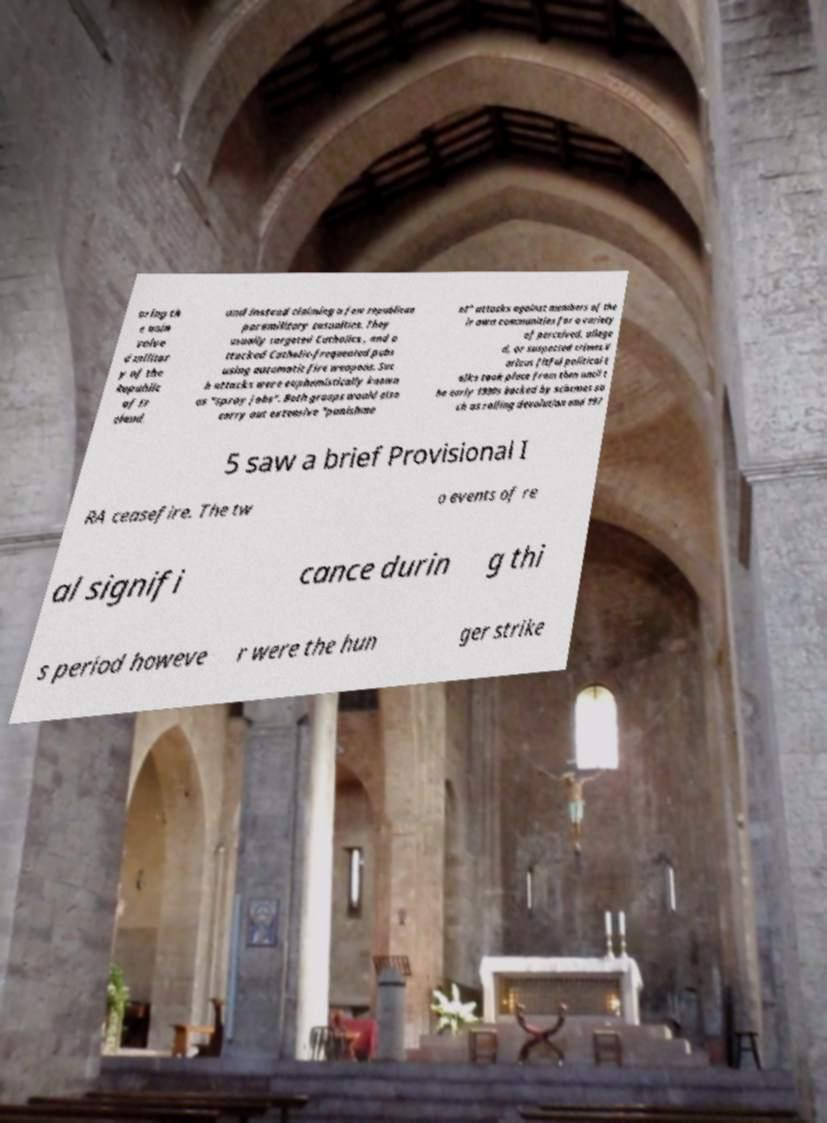Could you assist in decoding the text presented in this image and type it out clearly? oring th e unin volve d militar y of the Republic of Ir eland, and instead claiming a few republican paramilitary casualties. They usually targeted Catholics , and a ttacked Catholic-frequented pubs using automatic fire weapons. Suc h attacks were euphemistically known as "spray jobs". Both groups would also carry out extensive "punishme nt" attacks against members of the ir own communities for a variety of perceived, allege d, or suspected crimes.V arious fitful political t alks took place from then until t he early 1990s backed by schemes su ch as rolling devolution and 197 5 saw a brief Provisional I RA ceasefire. The tw o events of re al signifi cance durin g thi s period howeve r were the hun ger strike 